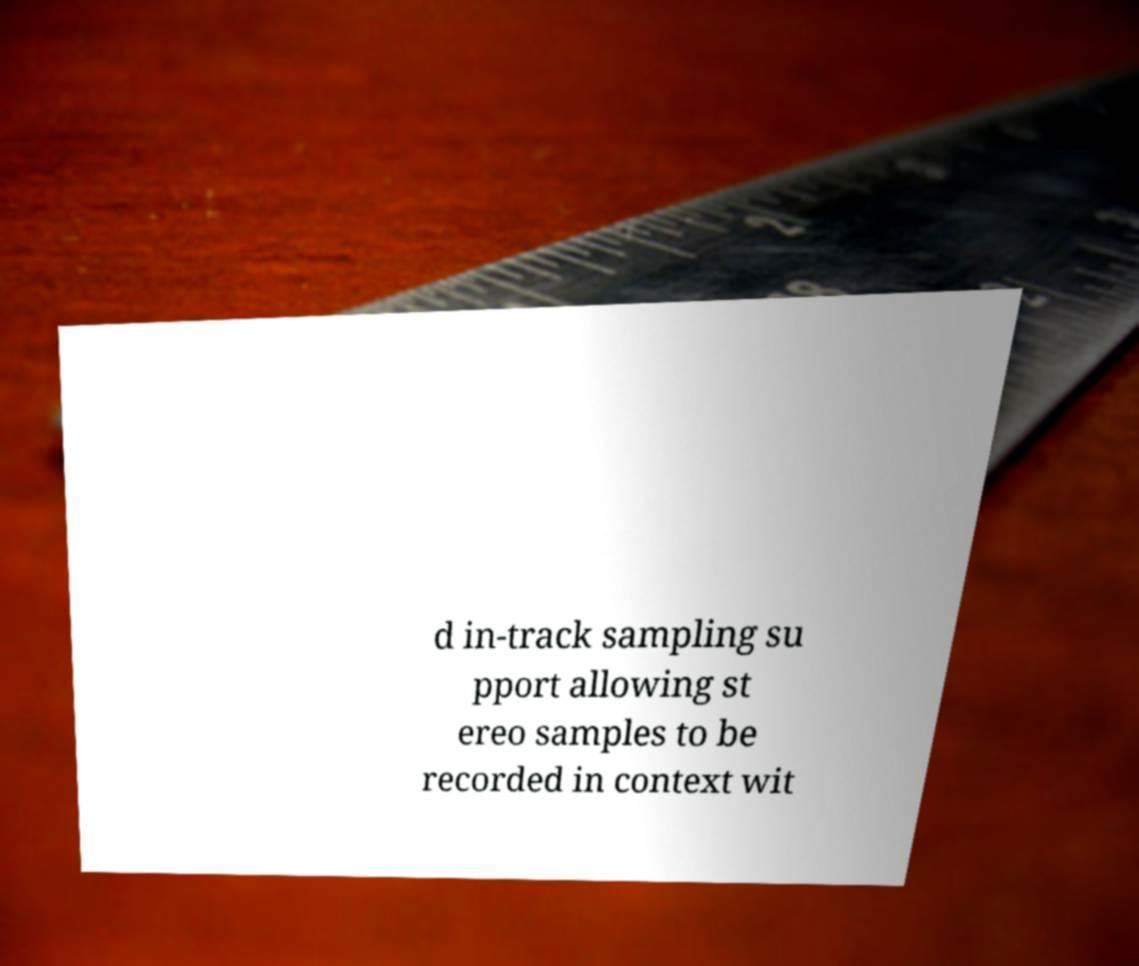Can you read and provide the text displayed in the image?This photo seems to have some interesting text. Can you extract and type it out for me? d in-track sampling su pport allowing st ereo samples to be recorded in context wit 